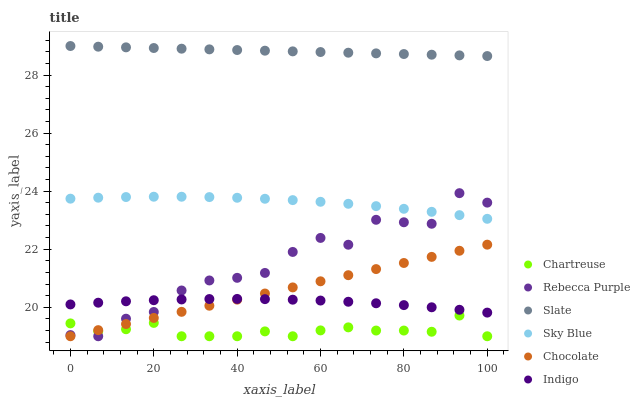Does Chartreuse have the minimum area under the curve?
Answer yes or no. Yes. Does Slate have the maximum area under the curve?
Answer yes or no. Yes. Does Chocolate have the minimum area under the curve?
Answer yes or no. No. Does Chocolate have the maximum area under the curve?
Answer yes or no. No. Is Slate the smoothest?
Answer yes or no. Yes. Is Rebecca Purple the roughest?
Answer yes or no. Yes. Is Chocolate the smoothest?
Answer yes or no. No. Is Chocolate the roughest?
Answer yes or no. No. Does Chocolate have the lowest value?
Answer yes or no. Yes. Does Slate have the lowest value?
Answer yes or no. No. Does Slate have the highest value?
Answer yes or no. Yes. Does Chocolate have the highest value?
Answer yes or no. No. Is Indigo less than Sky Blue?
Answer yes or no. Yes. Is Sky Blue greater than Chocolate?
Answer yes or no. Yes. Does Chartreuse intersect Chocolate?
Answer yes or no. Yes. Is Chartreuse less than Chocolate?
Answer yes or no. No. Is Chartreuse greater than Chocolate?
Answer yes or no. No. Does Indigo intersect Sky Blue?
Answer yes or no. No. 